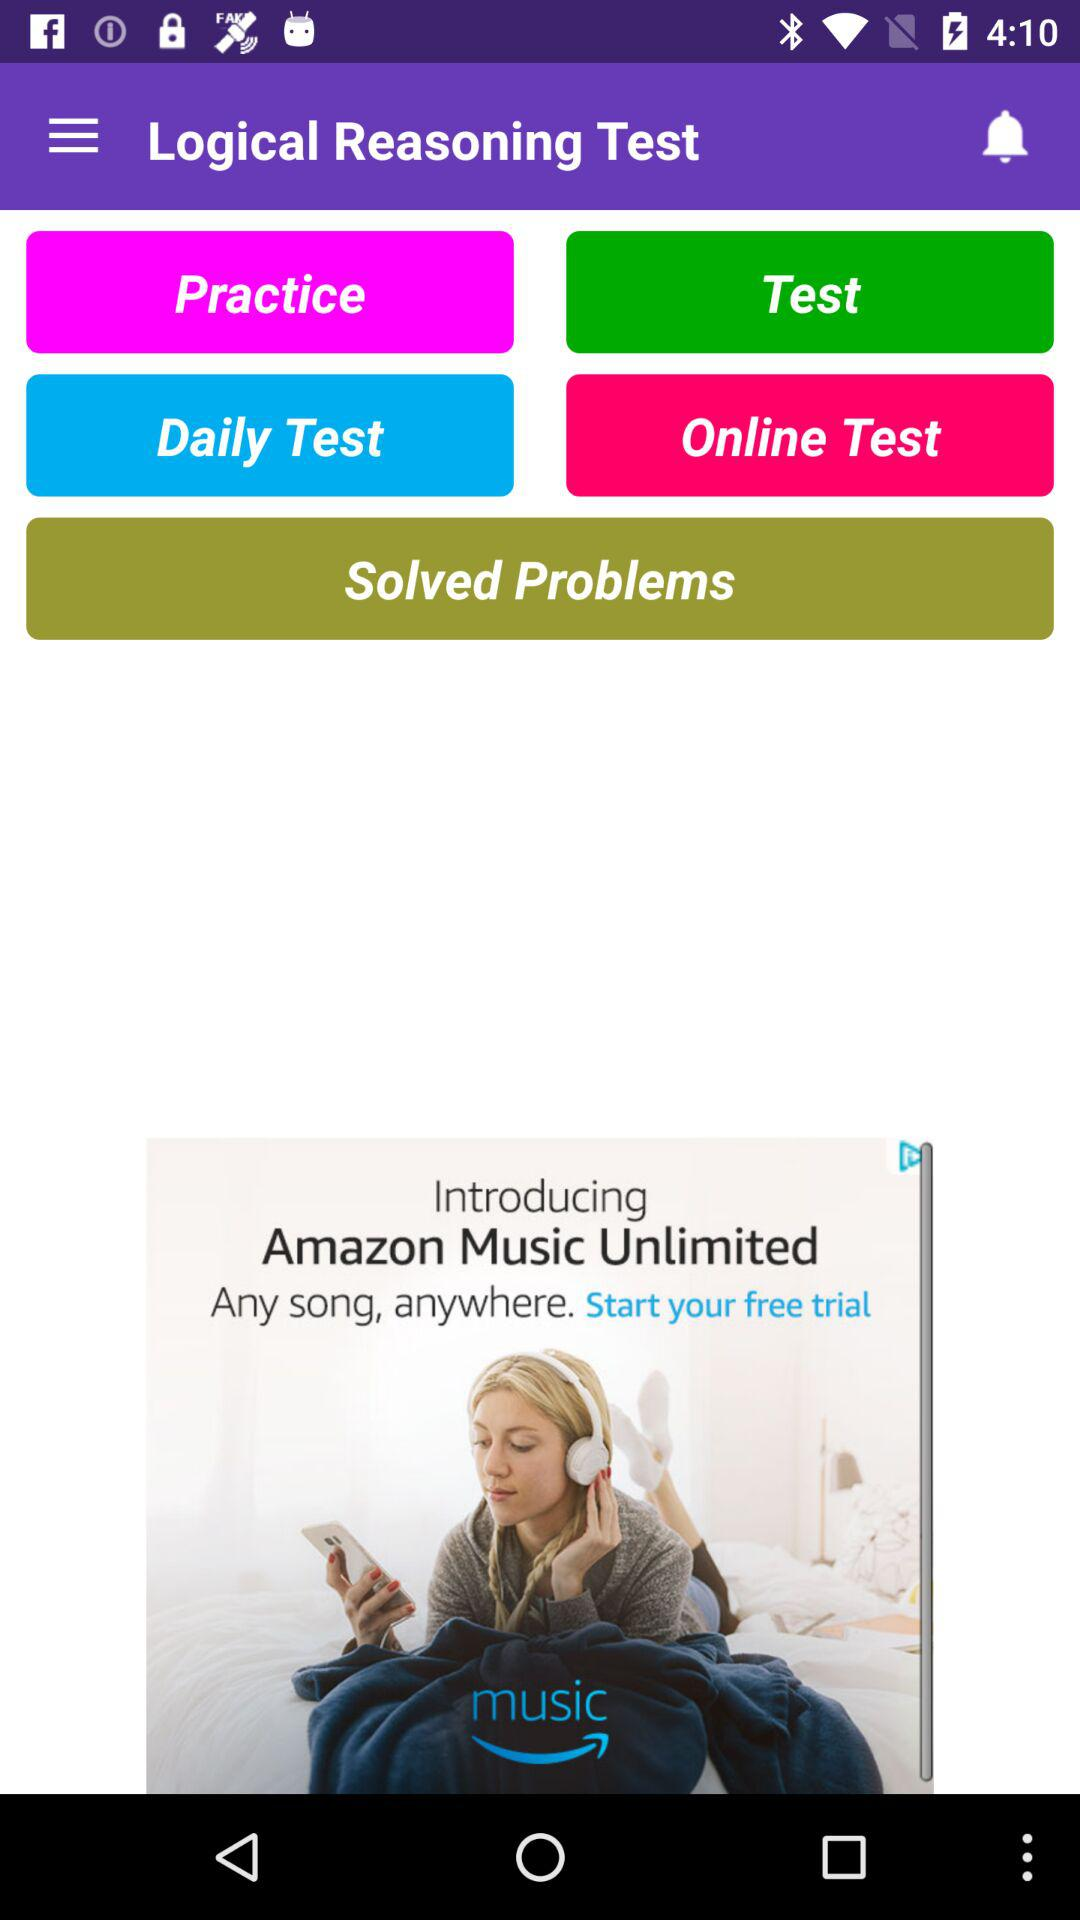What is the application name? The application name is "Logical Reasoning Test". 